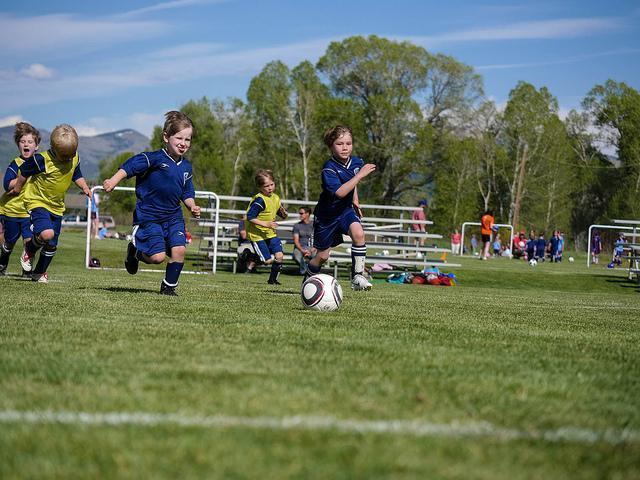How many people are in the picture?
Give a very brief answer. 5. How many baby giraffes are in the picture?
Give a very brief answer. 0. 